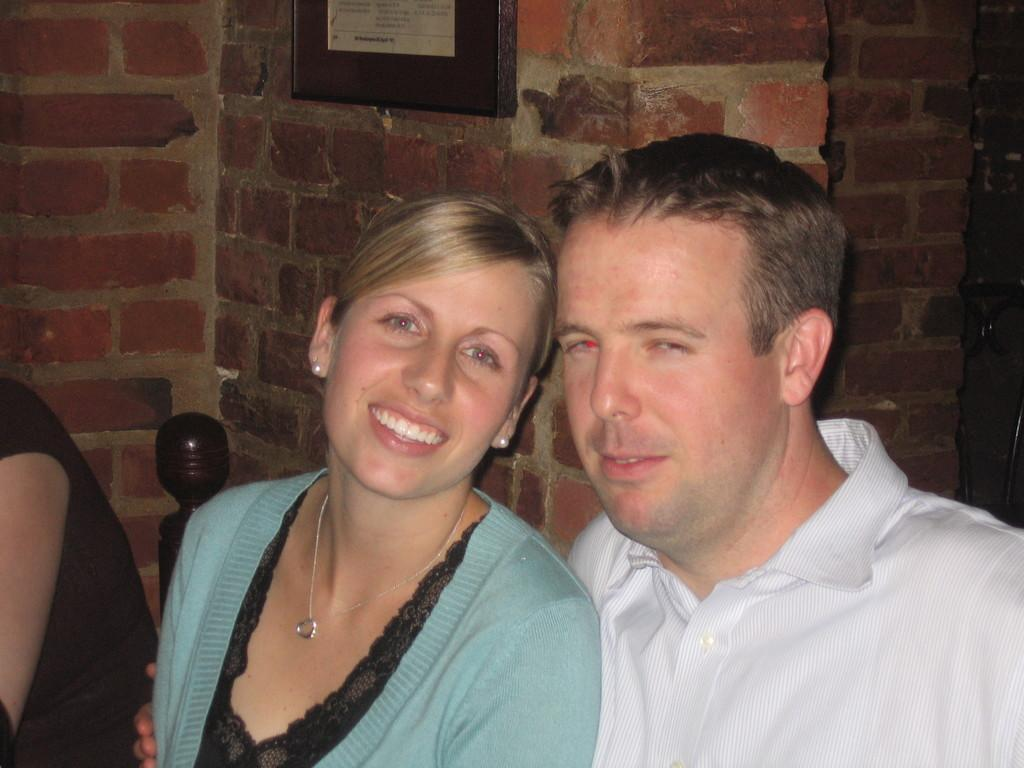How many people are in the image? There are three persons in the image. What are the persons doing in the image? The persons are sitting on chairs. What can be seen in the background of the image? There is a wall in the background of the image. Is there any decoration or object on the wall? Yes, there is a photo frame on the wall. What type of bat is hanging from the ceiling in the image? There is no bat present in the image; it features three persons sitting on chairs with a wall and a photo frame in the background. 